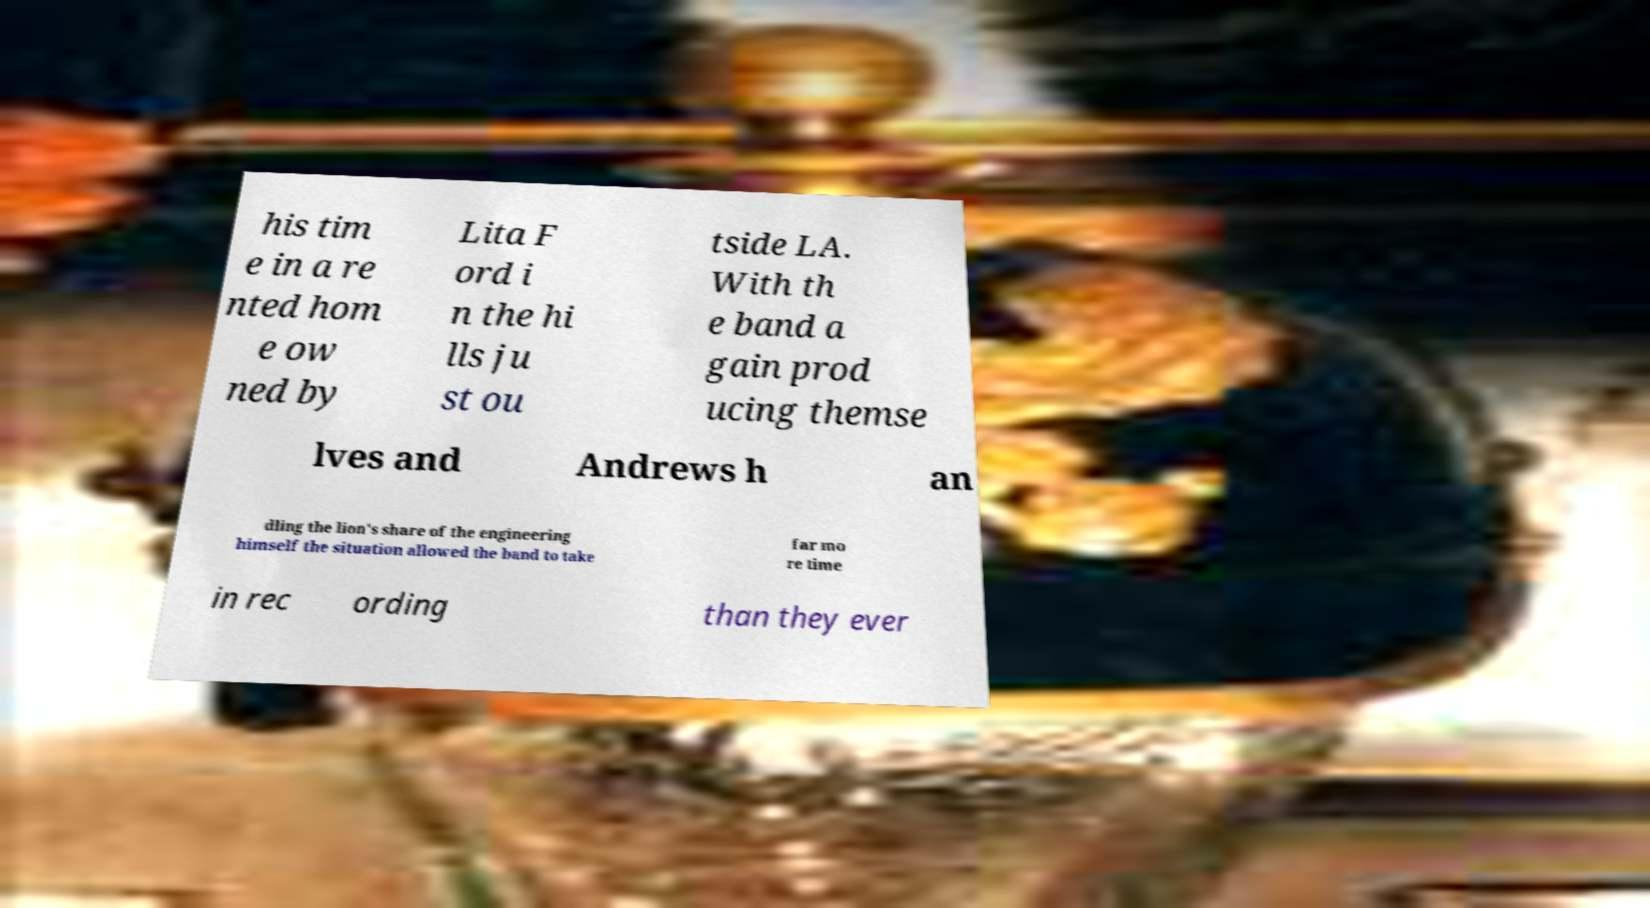For documentation purposes, I need the text within this image transcribed. Could you provide that? his tim e in a re nted hom e ow ned by Lita F ord i n the hi lls ju st ou tside LA. With th e band a gain prod ucing themse lves and Andrews h an dling the lion's share of the engineering himself the situation allowed the band to take far mo re time in rec ording than they ever 